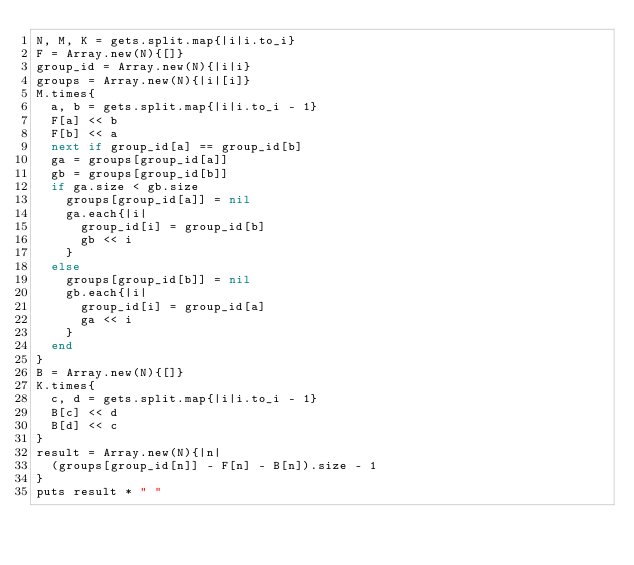<code> <loc_0><loc_0><loc_500><loc_500><_Ruby_>N, M, K = gets.split.map{|i|i.to_i}
F = Array.new(N){[]}
group_id = Array.new(N){|i|i}
groups = Array.new(N){|i|[i]}
M.times{
	a, b = gets.split.map{|i|i.to_i - 1}
	F[a] << b
	F[b] << a
	next if group_id[a] == group_id[b]
	ga = groups[group_id[a]]
	gb = groups[group_id[b]]
	if ga.size < gb.size
		groups[group_id[a]] = nil
		ga.each{|i|
			group_id[i] = group_id[b]
			gb << i
		}
	else
		groups[group_id[b]] = nil
		gb.each{|i|
			group_id[i] = group_id[a]
			ga << i
		}
	end
}
B = Array.new(N){[]}
K.times{
	c, d = gets.split.map{|i|i.to_i - 1}
	B[c] << d
	B[d] << c
}
result = Array.new(N){|n|
	(groups[group_id[n]] - F[n] - B[n]).size - 1
}
puts result * " "
</code> 